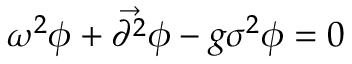Convert formula to latex. <formula><loc_0><loc_0><loc_500><loc_500>\omega ^ { 2 } \phi + { \vec { \partial ^ { 2 } } } \phi - g \sigma ^ { 2 } \phi = 0</formula> 